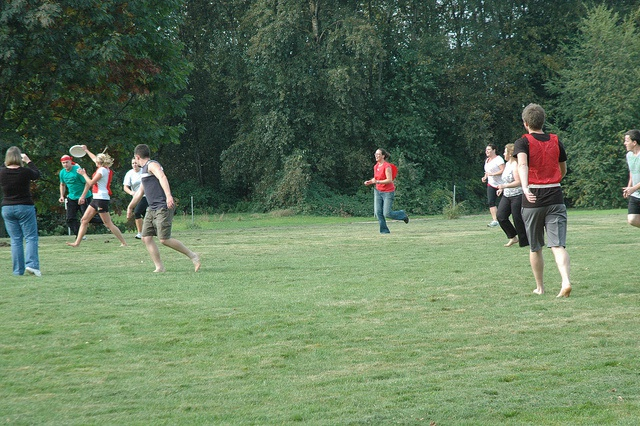Describe the objects in this image and their specific colors. I can see people in black, gray, brown, and darkgray tones, people in black, blue, gray, and teal tones, people in black, gray, darkgray, and ivory tones, people in black, white, gray, and darkgray tones, and people in black, white, darkgray, and gray tones in this image. 